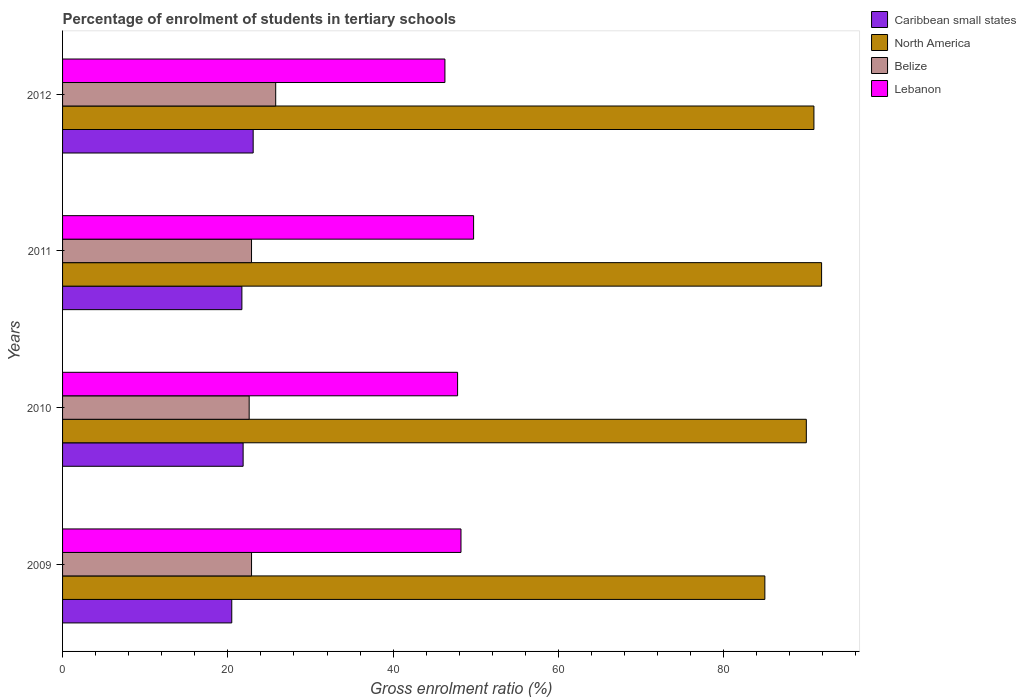Are the number of bars per tick equal to the number of legend labels?
Give a very brief answer. Yes. Are the number of bars on each tick of the Y-axis equal?
Keep it short and to the point. Yes. How many bars are there on the 1st tick from the top?
Make the answer very short. 4. In how many cases, is the number of bars for a given year not equal to the number of legend labels?
Ensure brevity in your answer.  0. What is the percentage of students enrolled in tertiary schools in Belize in 2011?
Make the answer very short. 22.86. Across all years, what is the maximum percentage of students enrolled in tertiary schools in North America?
Your response must be concise. 91.84. Across all years, what is the minimum percentage of students enrolled in tertiary schools in Lebanon?
Ensure brevity in your answer.  46.26. In which year was the percentage of students enrolled in tertiary schools in Lebanon maximum?
Give a very brief answer. 2011. What is the total percentage of students enrolled in tertiary schools in Lebanon in the graph?
Provide a succinct answer. 192. What is the difference between the percentage of students enrolled in tertiary schools in North America in 2009 and that in 2010?
Give a very brief answer. -5.02. What is the difference between the percentage of students enrolled in tertiary schools in Lebanon in 2010 and the percentage of students enrolled in tertiary schools in Caribbean small states in 2009?
Ensure brevity in your answer.  27.32. What is the average percentage of students enrolled in tertiary schools in Lebanon per year?
Ensure brevity in your answer.  48. In the year 2010, what is the difference between the percentage of students enrolled in tertiary schools in Caribbean small states and percentage of students enrolled in tertiary schools in Lebanon?
Ensure brevity in your answer.  -25.95. What is the ratio of the percentage of students enrolled in tertiary schools in Caribbean small states in 2009 to that in 2010?
Offer a terse response. 0.94. Is the percentage of students enrolled in tertiary schools in Belize in 2010 less than that in 2011?
Your response must be concise. Yes. What is the difference between the highest and the second highest percentage of students enrolled in tertiary schools in Caribbean small states?
Offer a terse response. 1.21. What is the difference between the highest and the lowest percentage of students enrolled in tertiary schools in Lebanon?
Ensure brevity in your answer.  3.47. In how many years, is the percentage of students enrolled in tertiary schools in Lebanon greater than the average percentage of students enrolled in tertiary schools in Lebanon taken over all years?
Give a very brief answer. 2. Is it the case that in every year, the sum of the percentage of students enrolled in tertiary schools in Caribbean small states and percentage of students enrolled in tertiary schools in Lebanon is greater than the sum of percentage of students enrolled in tertiary schools in Belize and percentage of students enrolled in tertiary schools in North America?
Provide a short and direct response. No. What does the 1st bar from the top in 2009 represents?
Ensure brevity in your answer.  Lebanon. What does the 4th bar from the bottom in 2010 represents?
Your answer should be compact. Lebanon. Is it the case that in every year, the sum of the percentage of students enrolled in tertiary schools in Belize and percentage of students enrolled in tertiary schools in Caribbean small states is greater than the percentage of students enrolled in tertiary schools in North America?
Provide a short and direct response. No. Are the values on the major ticks of X-axis written in scientific E-notation?
Provide a short and direct response. No. Does the graph contain any zero values?
Your answer should be very brief. No. Does the graph contain grids?
Your answer should be very brief. No. How many legend labels are there?
Make the answer very short. 4. How are the legend labels stacked?
Provide a short and direct response. Vertical. What is the title of the graph?
Your response must be concise. Percentage of enrolment of students in tertiary schools. Does "Swaziland" appear as one of the legend labels in the graph?
Your answer should be very brief. No. What is the label or title of the X-axis?
Give a very brief answer. Gross enrolment ratio (%). What is the Gross enrolment ratio (%) in Caribbean small states in 2009?
Offer a terse response. 20.47. What is the Gross enrolment ratio (%) of North America in 2009?
Offer a very short reply. 84.97. What is the Gross enrolment ratio (%) in Belize in 2009?
Offer a very short reply. 22.87. What is the Gross enrolment ratio (%) of Lebanon in 2009?
Your answer should be very brief. 48.21. What is the Gross enrolment ratio (%) of Caribbean small states in 2010?
Your response must be concise. 21.85. What is the Gross enrolment ratio (%) of North America in 2010?
Your answer should be very brief. 89.99. What is the Gross enrolment ratio (%) in Belize in 2010?
Provide a short and direct response. 22.58. What is the Gross enrolment ratio (%) of Lebanon in 2010?
Your response must be concise. 47.8. What is the Gross enrolment ratio (%) in Caribbean small states in 2011?
Provide a succinct answer. 21.7. What is the Gross enrolment ratio (%) of North America in 2011?
Make the answer very short. 91.84. What is the Gross enrolment ratio (%) of Belize in 2011?
Your response must be concise. 22.86. What is the Gross enrolment ratio (%) in Lebanon in 2011?
Your answer should be compact. 49.73. What is the Gross enrolment ratio (%) in Caribbean small states in 2012?
Your answer should be compact. 23.06. What is the Gross enrolment ratio (%) of North America in 2012?
Provide a succinct answer. 90.91. What is the Gross enrolment ratio (%) of Belize in 2012?
Your response must be concise. 25.79. What is the Gross enrolment ratio (%) of Lebanon in 2012?
Provide a short and direct response. 46.26. Across all years, what is the maximum Gross enrolment ratio (%) of Caribbean small states?
Your answer should be very brief. 23.06. Across all years, what is the maximum Gross enrolment ratio (%) of North America?
Give a very brief answer. 91.84. Across all years, what is the maximum Gross enrolment ratio (%) of Belize?
Provide a short and direct response. 25.79. Across all years, what is the maximum Gross enrolment ratio (%) of Lebanon?
Your answer should be compact. 49.73. Across all years, what is the minimum Gross enrolment ratio (%) of Caribbean small states?
Ensure brevity in your answer.  20.47. Across all years, what is the minimum Gross enrolment ratio (%) of North America?
Your answer should be very brief. 84.97. Across all years, what is the minimum Gross enrolment ratio (%) of Belize?
Offer a very short reply. 22.58. Across all years, what is the minimum Gross enrolment ratio (%) of Lebanon?
Give a very brief answer. 46.26. What is the total Gross enrolment ratio (%) in Caribbean small states in the graph?
Give a very brief answer. 87.08. What is the total Gross enrolment ratio (%) in North America in the graph?
Offer a terse response. 357.72. What is the total Gross enrolment ratio (%) of Belize in the graph?
Your response must be concise. 94.1. What is the total Gross enrolment ratio (%) of Lebanon in the graph?
Offer a very short reply. 192. What is the difference between the Gross enrolment ratio (%) in Caribbean small states in 2009 and that in 2010?
Offer a very short reply. -1.38. What is the difference between the Gross enrolment ratio (%) of North America in 2009 and that in 2010?
Your answer should be very brief. -5.02. What is the difference between the Gross enrolment ratio (%) of Belize in 2009 and that in 2010?
Make the answer very short. 0.29. What is the difference between the Gross enrolment ratio (%) of Lebanon in 2009 and that in 2010?
Your response must be concise. 0.41. What is the difference between the Gross enrolment ratio (%) in Caribbean small states in 2009 and that in 2011?
Your answer should be very brief. -1.23. What is the difference between the Gross enrolment ratio (%) in North America in 2009 and that in 2011?
Your answer should be compact. -6.86. What is the difference between the Gross enrolment ratio (%) in Belize in 2009 and that in 2011?
Provide a succinct answer. 0. What is the difference between the Gross enrolment ratio (%) in Lebanon in 2009 and that in 2011?
Your answer should be very brief. -1.53. What is the difference between the Gross enrolment ratio (%) of Caribbean small states in 2009 and that in 2012?
Give a very brief answer. -2.59. What is the difference between the Gross enrolment ratio (%) in North America in 2009 and that in 2012?
Give a very brief answer. -5.94. What is the difference between the Gross enrolment ratio (%) of Belize in 2009 and that in 2012?
Your answer should be compact. -2.92. What is the difference between the Gross enrolment ratio (%) of Lebanon in 2009 and that in 2012?
Ensure brevity in your answer.  1.94. What is the difference between the Gross enrolment ratio (%) of Caribbean small states in 2010 and that in 2011?
Your response must be concise. 0.15. What is the difference between the Gross enrolment ratio (%) in North America in 2010 and that in 2011?
Offer a terse response. -1.85. What is the difference between the Gross enrolment ratio (%) in Belize in 2010 and that in 2011?
Give a very brief answer. -0.28. What is the difference between the Gross enrolment ratio (%) in Lebanon in 2010 and that in 2011?
Offer a terse response. -1.94. What is the difference between the Gross enrolment ratio (%) of Caribbean small states in 2010 and that in 2012?
Your answer should be very brief. -1.21. What is the difference between the Gross enrolment ratio (%) of North America in 2010 and that in 2012?
Ensure brevity in your answer.  -0.92. What is the difference between the Gross enrolment ratio (%) of Belize in 2010 and that in 2012?
Your answer should be compact. -3.21. What is the difference between the Gross enrolment ratio (%) of Lebanon in 2010 and that in 2012?
Make the answer very short. 1.53. What is the difference between the Gross enrolment ratio (%) in Caribbean small states in 2011 and that in 2012?
Give a very brief answer. -1.36. What is the difference between the Gross enrolment ratio (%) of North America in 2011 and that in 2012?
Make the answer very short. 0.93. What is the difference between the Gross enrolment ratio (%) of Belize in 2011 and that in 2012?
Make the answer very short. -2.92. What is the difference between the Gross enrolment ratio (%) of Lebanon in 2011 and that in 2012?
Offer a very short reply. 3.47. What is the difference between the Gross enrolment ratio (%) in Caribbean small states in 2009 and the Gross enrolment ratio (%) in North America in 2010?
Make the answer very short. -69.52. What is the difference between the Gross enrolment ratio (%) in Caribbean small states in 2009 and the Gross enrolment ratio (%) in Belize in 2010?
Your answer should be very brief. -2.11. What is the difference between the Gross enrolment ratio (%) of Caribbean small states in 2009 and the Gross enrolment ratio (%) of Lebanon in 2010?
Provide a succinct answer. -27.32. What is the difference between the Gross enrolment ratio (%) in North America in 2009 and the Gross enrolment ratio (%) in Belize in 2010?
Provide a short and direct response. 62.4. What is the difference between the Gross enrolment ratio (%) of North America in 2009 and the Gross enrolment ratio (%) of Lebanon in 2010?
Provide a short and direct response. 37.18. What is the difference between the Gross enrolment ratio (%) of Belize in 2009 and the Gross enrolment ratio (%) of Lebanon in 2010?
Your response must be concise. -24.93. What is the difference between the Gross enrolment ratio (%) in Caribbean small states in 2009 and the Gross enrolment ratio (%) in North America in 2011?
Your answer should be compact. -71.37. What is the difference between the Gross enrolment ratio (%) in Caribbean small states in 2009 and the Gross enrolment ratio (%) in Belize in 2011?
Keep it short and to the point. -2.39. What is the difference between the Gross enrolment ratio (%) in Caribbean small states in 2009 and the Gross enrolment ratio (%) in Lebanon in 2011?
Provide a short and direct response. -29.26. What is the difference between the Gross enrolment ratio (%) of North America in 2009 and the Gross enrolment ratio (%) of Belize in 2011?
Provide a short and direct response. 62.11. What is the difference between the Gross enrolment ratio (%) of North America in 2009 and the Gross enrolment ratio (%) of Lebanon in 2011?
Your answer should be compact. 35.24. What is the difference between the Gross enrolment ratio (%) of Belize in 2009 and the Gross enrolment ratio (%) of Lebanon in 2011?
Offer a very short reply. -26.87. What is the difference between the Gross enrolment ratio (%) in Caribbean small states in 2009 and the Gross enrolment ratio (%) in North America in 2012?
Make the answer very short. -70.44. What is the difference between the Gross enrolment ratio (%) in Caribbean small states in 2009 and the Gross enrolment ratio (%) in Belize in 2012?
Your response must be concise. -5.32. What is the difference between the Gross enrolment ratio (%) of Caribbean small states in 2009 and the Gross enrolment ratio (%) of Lebanon in 2012?
Your answer should be very brief. -25.79. What is the difference between the Gross enrolment ratio (%) in North America in 2009 and the Gross enrolment ratio (%) in Belize in 2012?
Keep it short and to the point. 59.19. What is the difference between the Gross enrolment ratio (%) of North America in 2009 and the Gross enrolment ratio (%) of Lebanon in 2012?
Offer a very short reply. 38.71. What is the difference between the Gross enrolment ratio (%) of Belize in 2009 and the Gross enrolment ratio (%) of Lebanon in 2012?
Keep it short and to the point. -23.4. What is the difference between the Gross enrolment ratio (%) in Caribbean small states in 2010 and the Gross enrolment ratio (%) in North America in 2011?
Offer a terse response. -69.99. What is the difference between the Gross enrolment ratio (%) of Caribbean small states in 2010 and the Gross enrolment ratio (%) of Belize in 2011?
Ensure brevity in your answer.  -1.02. What is the difference between the Gross enrolment ratio (%) of Caribbean small states in 2010 and the Gross enrolment ratio (%) of Lebanon in 2011?
Give a very brief answer. -27.89. What is the difference between the Gross enrolment ratio (%) of North America in 2010 and the Gross enrolment ratio (%) of Belize in 2011?
Offer a very short reply. 67.13. What is the difference between the Gross enrolment ratio (%) of North America in 2010 and the Gross enrolment ratio (%) of Lebanon in 2011?
Offer a very short reply. 40.26. What is the difference between the Gross enrolment ratio (%) in Belize in 2010 and the Gross enrolment ratio (%) in Lebanon in 2011?
Make the answer very short. -27.15. What is the difference between the Gross enrolment ratio (%) in Caribbean small states in 2010 and the Gross enrolment ratio (%) in North America in 2012?
Make the answer very short. -69.06. What is the difference between the Gross enrolment ratio (%) in Caribbean small states in 2010 and the Gross enrolment ratio (%) in Belize in 2012?
Offer a terse response. -3.94. What is the difference between the Gross enrolment ratio (%) in Caribbean small states in 2010 and the Gross enrolment ratio (%) in Lebanon in 2012?
Your answer should be very brief. -24.42. What is the difference between the Gross enrolment ratio (%) of North America in 2010 and the Gross enrolment ratio (%) of Belize in 2012?
Your answer should be very brief. 64.21. What is the difference between the Gross enrolment ratio (%) in North America in 2010 and the Gross enrolment ratio (%) in Lebanon in 2012?
Ensure brevity in your answer.  43.73. What is the difference between the Gross enrolment ratio (%) in Belize in 2010 and the Gross enrolment ratio (%) in Lebanon in 2012?
Provide a short and direct response. -23.68. What is the difference between the Gross enrolment ratio (%) in Caribbean small states in 2011 and the Gross enrolment ratio (%) in North America in 2012?
Offer a terse response. -69.21. What is the difference between the Gross enrolment ratio (%) in Caribbean small states in 2011 and the Gross enrolment ratio (%) in Belize in 2012?
Provide a succinct answer. -4.09. What is the difference between the Gross enrolment ratio (%) of Caribbean small states in 2011 and the Gross enrolment ratio (%) of Lebanon in 2012?
Give a very brief answer. -24.57. What is the difference between the Gross enrolment ratio (%) of North America in 2011 and the Gross enrolment ratio (%) of Belize in 2012?
Your response must be concise. 66.05. What is the difference between the Gross enrolment ratio (%) in North America in 2011 and the Gross enrolment ratio (%) in Lebanon in 2012?
Keep it short and to the point. 45.57. What is the difference between the Gross enrolment ratio (%) of Belize in 2011 and the Gross enrolment ratio (%) of Lebanon in 2012?
Provide a succinct answer. -23.4. What is the average Gross enrolment ratio (%) in Caribbean small states per year?
Give a very brief answer. 21.77. What is the average Gross enrolment ratio (%) in North America per year?
Make the answer very short. 89.43. What is the average Gross enrolment ratio (%) of Belize per year?
Your response must be concise. 23.52. What is the average Gross enrolment ratio (%) in Lebanon per year?
Provide a short and direct response. 48. In the year 2009, what is the difference between the Gross enrolment ratio (%) of Caribbean small states and Gross enrolment ratio (%) of North America?
Ensure brevity in your answer.  -64.5. In the year 2009, what is the difference between the Gross enrolment ratio (%) in Caribbean small states and Gross enrolment ratio (%) in Belize?
Offer a terse response. -2.39. In the year 2009, what is the difference between the Gross enrolment ratio (%) in Caribbean small states and Gross enrolment ratio (%) in Lebanon?
Your answer should be very brief. -27.74. In the year 2009, what is the difference between the Gross enrolment ratio (%) in North America and Gross enrolment ratio (%) in Belize?
Provide a succinct answer. 62.11. In the year 2009, what is the difference between the Gross enrolment ratio (%) of North America and Gross enrolment ratio (%) of Lebanon?
Offer a terse response. 36.77. In the year 2009, what is the difference between the Gross enrolment ratio (%) in Belize and Gross enrolment ratio (%) in Lebanon?
Offer a terse response. -25.34. In the year 2010, what is the difference between the Gross enrolment ratio (%) of Caribbean small states and Gross enrolment ratio (%) of North America?
Provide a succinct answer. -68.15. In the year 2010, what is the difference between the Gross enrolment ratio (%) in Caribbean small states and Gross enrolment ratio (%) in Belize?
Ensure brevity in your answer.  -0.73. In the year 2010, what is the difference between the Gross enrolment ratio (%) in Caribbean small states and Gross enrolment ratio (%) in Lebanon?
Provide a short and direct response. -25.95. In the year 2010, what is the difference between the Gross enrolment ratio (%) in North America and Gross enrolment ratio (%) in Belize?
Your response must be concise. 67.41. In the year 2010, what is the difference between the Gross enrolment ratio (%) of North America and Gross enrolment ratio (%) of Lebanon?
Offer a terse response. 42.2. In the year 2010, what is the difference between the Gross enrolment ratio (%) in Belize and Gross enrolment ratio (%) in Lebanon?
Keep it short and to the point. -25.22. In the year 2011, what is the difference between the Gross enrolment ratio (%) in Caribbean small states and Gross enrolment ratio (%) in North America?
Provide a short and direct response. -70.14. In the year 2011, what is the difference between the Gross enrolment ratio (%) in Caribbean small states and Gross enrolment ratio (%) in Belize?
Ensure brevity in your answer.  -1.17. In the year 2011, what is the difference between the Gross enrolment ratio (%) in Caribbean small states and Gross enrolment ratio (%) in Lebanon?
Make the answer very short. -28.04. In the year 2011, what is the difference between the Gross enrolment ratio (%) of North America and Gross enrolment ratio (%) of Belize?
Offer a very short reply. 68.98. In the year 2011, what is the difference between the Gross enrolment ratio (%) of North America and Gross enrolment ratio (%) of Lebanon?
Provide a short and direct response. 42.11. In the year 2011, what is the difference between the Gross enrolment ratio (%) of Belize and Gross enrolment ratio (%) of Lebanon?
Offer a very short reply. -26.87. In the year 2012, what is the difference between the Gross enrolment ratio (%) of Caribbean small states and Gross enrolment ratio (%) of North America?
Offer a very short reply. -67.85. In the year 2012, what is the difference between the Gross enrolment ratio (%) of Caribbean small states and Gross enrolment ratio (%) of Belize?
Provide a succinct answer. -2.73. In the year 2012, what is the difference between the Gross enrolment ratio (%) in Caribbean small states and Gross enrolment ratio (%) in Lebanon?
Provide a succinct answer. -23.2. In the year 2012, what is the difference between the Gross enrolment ratio (%) of North America and Gross enrolment ratio (%) of Belize?
Offer a very short reply. 65.12. In the year 2012, what is the difference between the Gross enrolment ratio (%) in North America and Gross enrolment ratio (%) in Lebanon?
Give a very brief answer. 44.65. In the year 2012, what is the difference between the Gross enrolment ratio (%) in Belize and Gross enrolment ratio (%) in Lebanon?
Make the answer very short. -20.48. What is the ratio of the Gross enrolment ratio (%) of Caribbean small states in 2009 to that in 2010?
Your answer should be compact. 0.94. What is the ratio of the Gross enrolment ratio (%) in North America in 2009 to that in 2010?
Make the answer very short. 0.94. What is the ratio of the Gross enrolment ratio (%) of Belize in 2009 to that in 2010?
Offer a terse response. 1.01. What is the ratio of the Gross enrolment ratio (%) of Lebanon in 2009 to that in 2010?
Make the answer very short. 1.01. What is the ratio of the Gross enrolment ratio (%) in Caribbean small states in 2009 to that in 2011?
Your response must be concise. 0.94. What is the ratio of the Gross enrolment ratio (%) in North America in 2009 to that in 2011?
Give a very brief answer. 0.93. What is the ratio of the Gross enrolment ratio (%) in Belize in 2009 to that in 2011?
Make the answer very short. 1. What is the ratio of the Gross enrolment ratio (%) of Lebanon in 2009 to that in 2011?
Provide a succinct answer. 0.97. What is the ratio of the Gross enrolment ratio (%) in Caribbean small states in 2009 to that in 2012?
Keep it short and to the point. 0.89. What is the ratio of the Gross enrolment ratio (%) of North America in 2009 to that in 2012?
Provide a short and direct response. 0.93. What is the ratio of the Gross enrolment ratio (%) in Belize in 2009 to that in 2012?
Provide a short and direct response. 0.89. What is the ratio of the Gross enrolment ratio (%) of Lebanon in 2009 to that in 2012?
Your response must be concise. 1.04. What is the ratio of the Gross enrolment ratio (%) of North America in 2010 to that in 2011?
Offer a terse response. 0.98. What is the ratio of the Gross enrolment ratio (%) of Belize in 2010 to that in 2011?
Provide a succinct answer. 0.99. What is the ratio of the Gross enrolment ratio (%) in Lebanon in 2010 to that in 2011?
Keep it short and to the point. 0.96. What is the ratio of the Gross enrolment ratio (%) in Belize in 2010 to that in 2012?
Your answer should be very brief. 0.88. What is the ratio of the Gross enrolment ratio (%) of Lebanon in 2010 to that in 2012?
Your response must be concise. 1.03. What is the ratio of the Gross enrolment ratio (%) of Caribbean small states in 2011 to that in 2012?
Your response must be concise. 0.94. What is the ratio of the Gross enrolment ratio (%) in North America in 2011 to that in 2012?
Make the answer very short. 1.01. What is the ratio of the Gross enrolment ratio (%) of Belize in 2011 to that in 2012?
Your answer should be very brief. 0.89. What is the ratio of the Gross enrolment ratio (%) in Lebanon in 2011 to that in 2012?
Give a very brief answer. 1.07. What is the difference between the highest and the second highest Gross enrolment ratio (%) of Caribbean small states?
Provide a succinct answer. 1.21. What is the difference between the highest and the second highest Gross enrolment ratio (%) of North America?
Provide a succinct answer. 0.93. What is the difference between the highest and the second highest Gross enrolment ratio (%) in Belize?
Give a very brief answer. 2.92. What is the difference between the highest and the second highest Gross enrolment ratio (%) of Lebanon?
Ensure brevity in your answer.  1.53. What is the difference between the highest and the lowest Gross enrolment ratio (%) of Caribbean small states?
Provide a succinct answer. 2.59. What is the difference between the highest and the lowest Gross enrolment ratio (%) in North America?
Make the answer very short. 6.86. What is the difference between the highest and the lowest Gross enrolment ratio (%) in Belize?
Your answer should be very brief. 3.21. What is the difference between the highest and the lowest Gross enrolment ratio (%) of Lebanon?
Offer a very short reply. 3.47. 